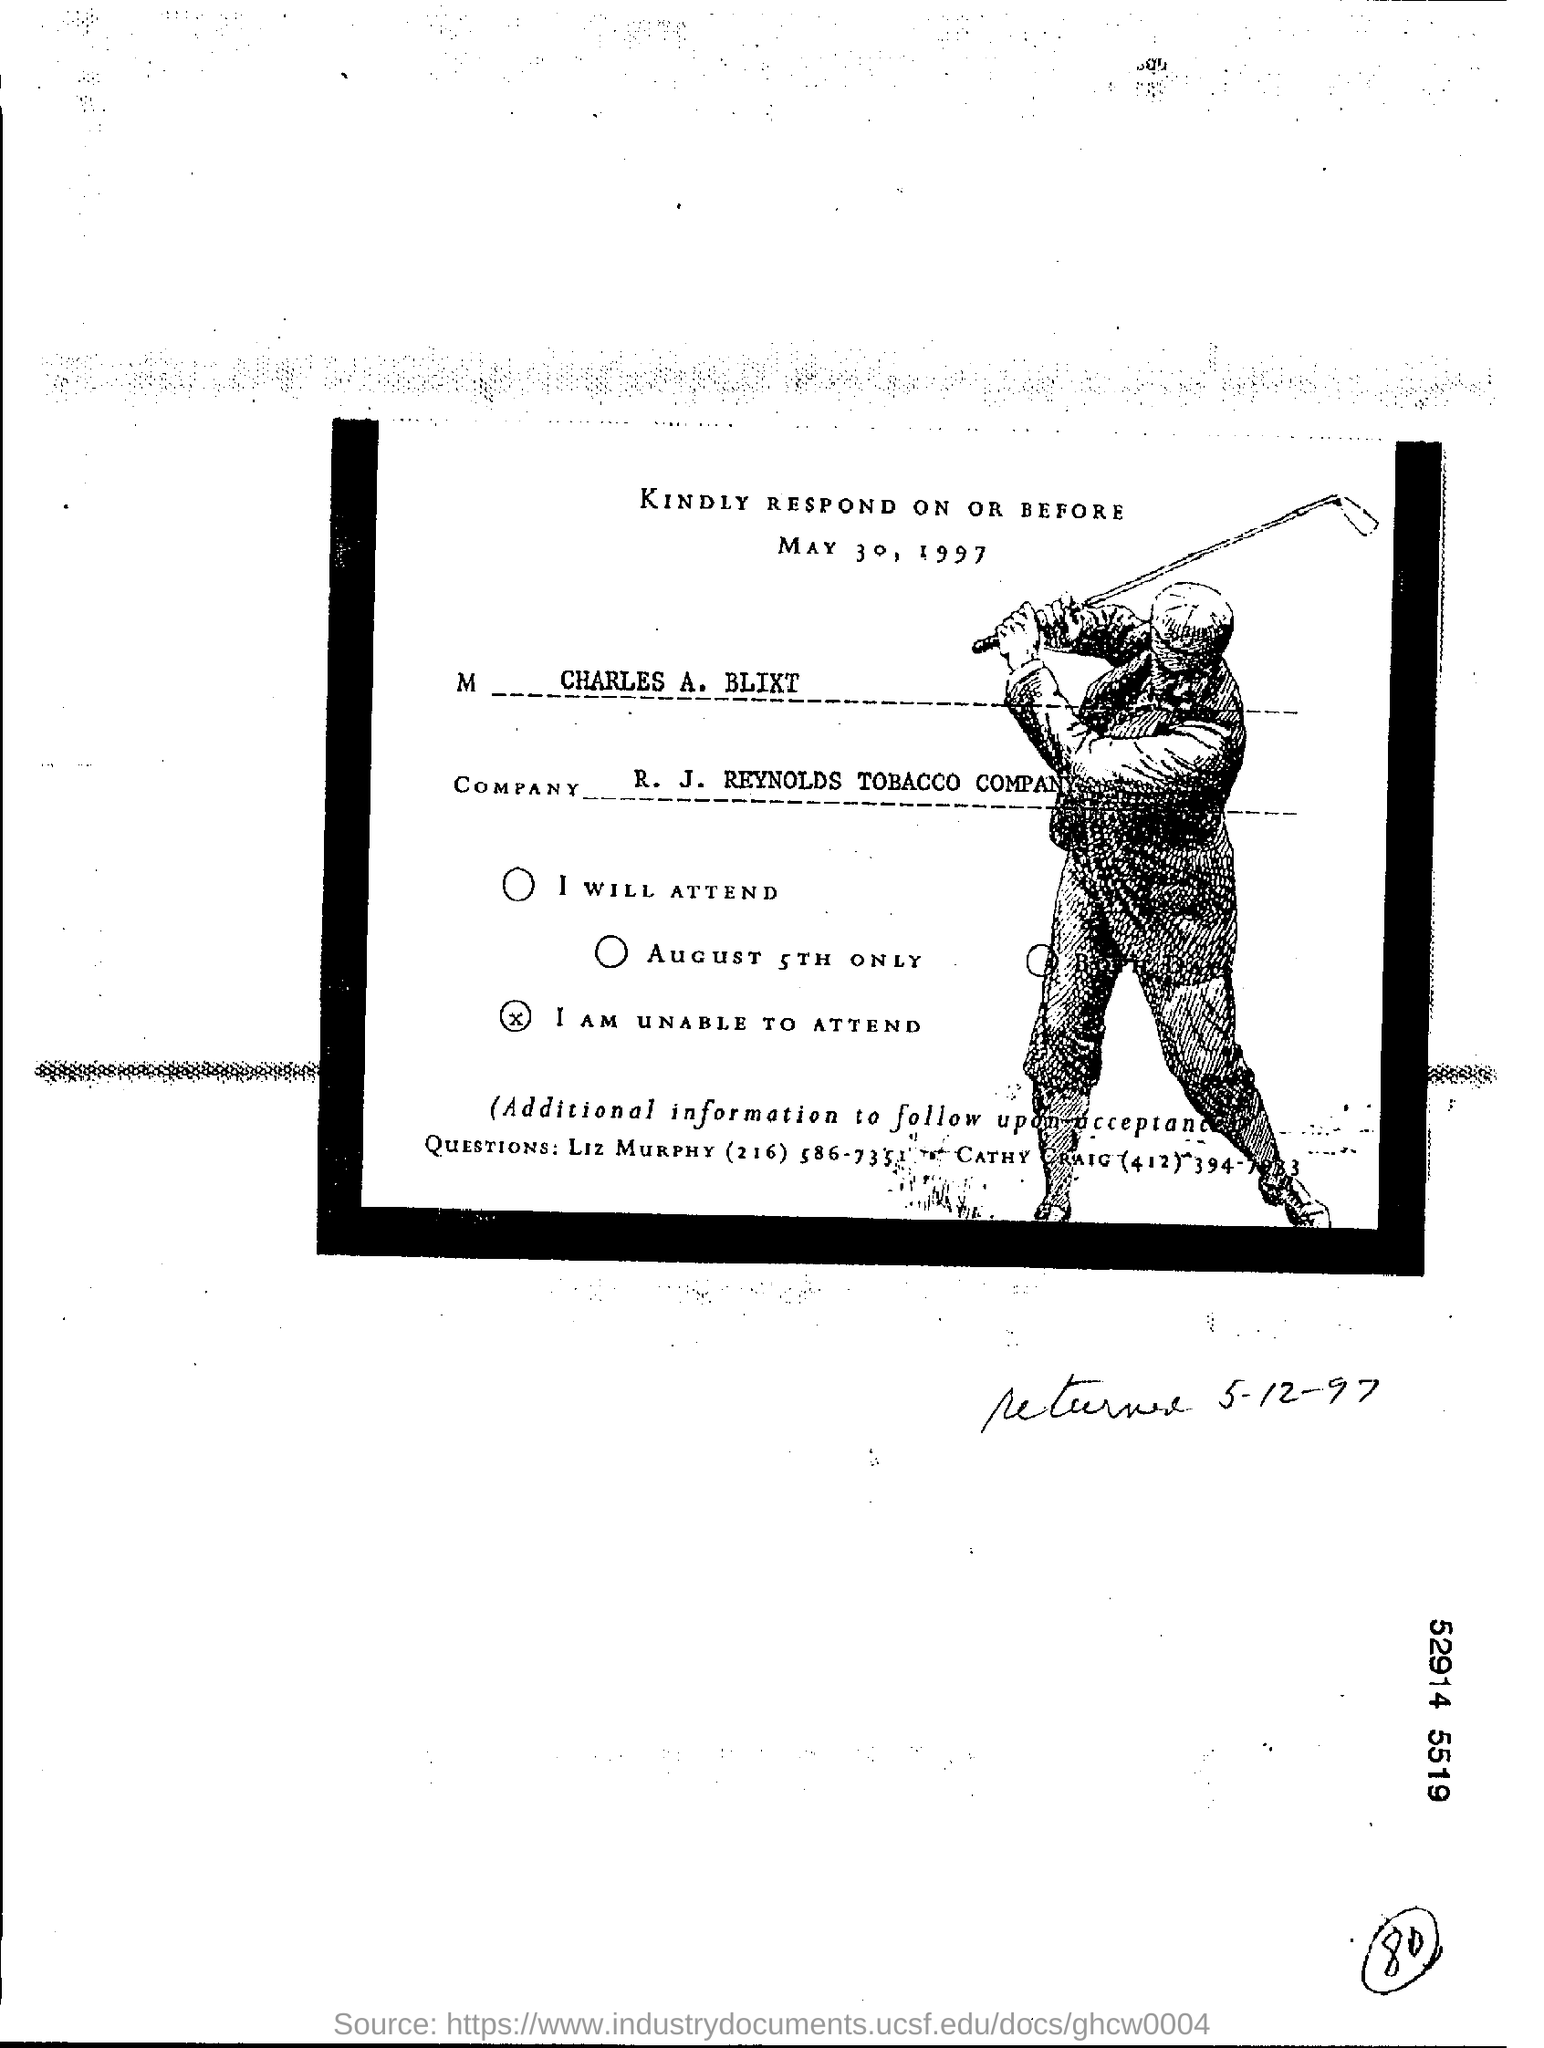When is the last day to respond?
Give a very brief answer. MAY 30, 1997. Name any one to contact if any queries?
Your response must be concise. LIZ MURPHY. What is the name of the company mentioned?
Give a very brief answer. R. J. REYNOLDS TOBACCO COMPANY. 